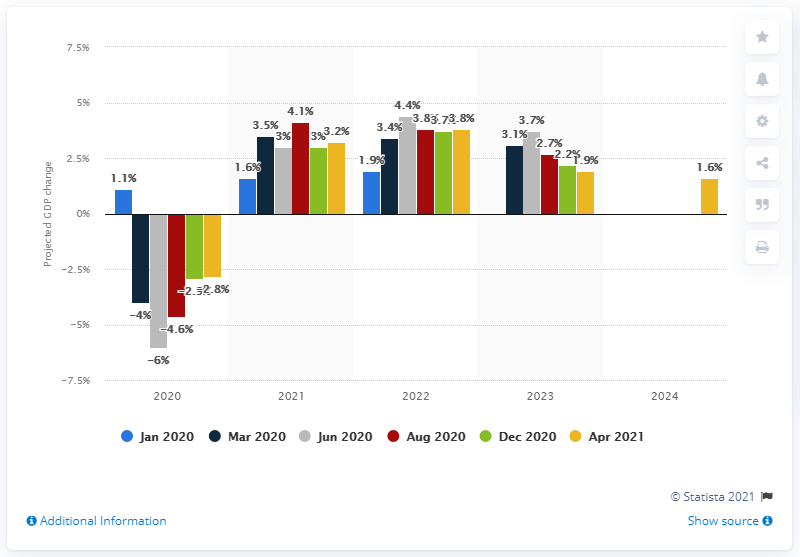Point out several critical features in this image. According to the forecast, Sweden's Gross Domestic Product (GDP) growth for 2021 is expected to be 3.2%. 